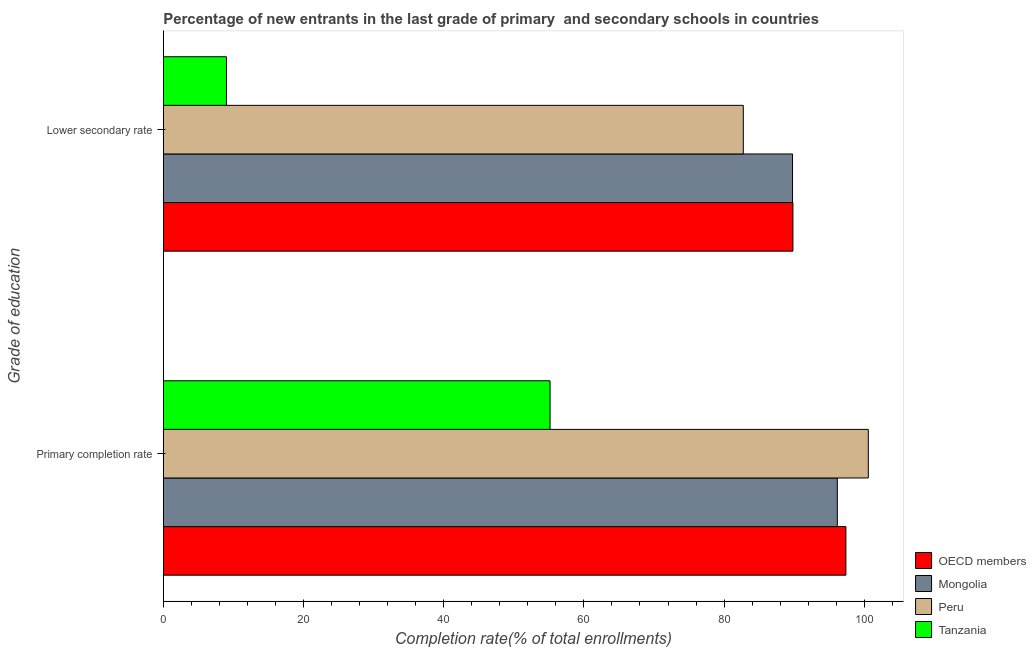How many different coloured bars are there?
Ensure brevity in your answer.  4. How many groups of bars are there?
Your answer should be compact. 2. Are the number of bars per tick equal to the number of legend labels?
Offer a very short reply. Yes. How many bars are there on the 2nd tick from the bottom?
Offer a terse response. 4. What is the label of the 2nd group of bars from the top?
Offer a terse response. Primary completion rate. What is the completion rate in primary schools in Tanzania?
Provide a succinct answer. 55.18. Across all countries, what is the maximum completion rate in primary schools?
Offer a terse response. 100.57. Across all countries, what is the minimum completion rate in secondary schools?
Provide a succinct answer. 9.02. In which country was the completion rate in primary schools maximum?
Your answer should be compact. Peru. In which country was the completion rate in primary schools minimum?
Offer a terse response. Tanzania. What is the total completion rate in primary schools in the graph?
Provide a succinct answer. 349.28. What is the difference between the completion rate in primary schools in OECD members and that in Tanzania?
Provide a short and direct response. 42.2. What is the difference between the completion rate in secondary schools in OECD members and the completion rate in primary schools in Mongolia?
Ensure brevity in your answer.  -6.33. What is the average completion rate in primary schools per country?
Keep it short and to the point. 87.32. What is the difference between the completion rate in primary schools and completion rate in secondary schools in Peru?
Provide a succinct answer. 17.83. What is the ratio of the completion rate in primary schools in Peru to that in OECD members?
Keep it short and to the point. 1.03. Is the completion rate in primary schools in Mongolia less than that in OECD members?
Provide a succinct answer. Yes. In how many countries, is the completion rate in secondary schools greater than the average completion rate in secondary schools taken over all countries?
Offer a terse response. 3. What does the 2nd bar from the top in Lower secondary rate represents?
Ensure brevity in your answer.  Peru. What does the 1st bar from the bottom in Lower secondary rate represents?
Provide a short and direct response. OECD members. How many bars are there?
Your response must be concise. 8. Are all the bars in the graph horizontal?
Offer a very short reply. Yes. What is the difference between two consecutive major ticks on the X-axis?
Make the answer very short. 20. Does the graph contain any zero values?
Your answer should be compact. No. Where does the legend appear in the graph?
Keep it short and to the point. Bottom right. How many legend labels are there?
Give a very brief answer. 4. How are the legend labels stacked?
Provide a short and direct response. Vertical. What is the title of the graph?
Ensure brevity in your answer.  Percentage of new entrants in the last grade of primary  and secondary schools in countries. Does "Poland" appear as one of the legend labels in the graph?
Ensure brevity in your answer.  No. What is the label or title of the X-axis?
Ensure brevity in your answer.  Completion rate(% of total enrollments). What is the label or title of the Y-axis?
Offer a very short reply. Grade of education. What is the Completion rate(% of total enrollments) in OECD members in Primary completion rate?
Provide a succinct answer. 97.37. What is the Completion rate(% of total enrollments) in Mongolia in Primary completion rate?
Your answer should be compact. 96.15. What is the Completion rate(% of total enrollments) in Peru in Primary completion rate?
Provide a short and direct response. 100.57. What is the Completion rate(% of total enrollments) of Tanzania in Primary completion rate?
Give a very brief answer. 55.18. What is the Completion rate(% of total enrollments) of OECD members in Lower secondary rate?
Keep it short and to the point. 89.82. What is the Completion rate(% of total enrollments) of Mongolia in Lower secondary rate?
Your answer should be compact. 89.76. What is the Completion rate(% of total enrollments) of Peru in Lower secondary rate?
Provide a short and direct response. 82.74. What is the Completion rate(% of total enrollments) in Tanzania in Lower secondary rate?
Offer a very short reply. 9.02. Across all Grade of education, what is the maximum Completion rate(% of total enrollments) of OECD members?
Make the answer very short. 97.37. Across all Grade of education, what is the maximum Completion rate(% of total enrollments) of Mongolia?
Make the answer very short. 96.15. Across all Grade of education, what is the maximum Completion rate(% of total enrollments) in Peru?
Offer a very short reply. 100.57. Across all Grade of education, what is the maximum Completion rate(% of total enrollments) of Tanzania?
Provide a short and direct response. 55.18. Across all Grade of education, what is the minimum Completion rate(% of total enrollments) of OECD members?
Provide a succinct answer. 89.82. Across all Grade of education, what is the minimum Completion rate(% of total enrollments) of Mongolia?
Make the answer very short. 89.76. Across all Grade of education, what is the minimum Completion rate(% of total enrollments) in Peru?
Provide a short and direct response. 82.74. Across all Grade of education, what is the minimum Completion rate(% of total enrollments) in Tanzania?
Provide a succinct answer. 9.02. What is the total Completion rate(% of total enrollments) in OECD members in the graph?
Your response must be concise. 187.19. What is the total Completion rate(% of total enrollments) in Mongolia in the graph?
Offer a terse response. 185.92. What is the total Completion rate(% of total enrollments) of Peru in the graph?
Your response must be concise. 183.31. What is the total Completion rate(% of total enrollments) in Tanzania in the graph?
Keep it short and to the point. 64.19. What is the difference between the Completion rate(% of total enrollments) of OECD members in Primary completion rate and that in Lower secondary rate?
Your answer should be very brief. 7.56. What is the difference between the Completion rate(% of total enrollments) of Mongolia in Primary completion rate and that in Lower secondary rate?
Your response must be concise. 6.39. What is the difference between the Completion rate(% of total enrollments) in Peru in Primary completion rate and that in Lower secondary rate?
Ensure brevity in your answer.  17.83. What is the difference between the Completion rate(% of total enrollments) in Tanzania in Primary completion rate and that in Lower secondary rate?
Provide a short and direct response. 46.16. What is the difference between the Completion rate(% of total enrollments) in OECD members in Primary completion rate and the Completion rate(% of total enrollments) in Mongolia in Lower secondary rate?
Your answer should be compact. 7.61. What is the difference between the Completion rate(% of total enrollments) in OECD members in Primary completion rate and the Completion rate(% of total enrollments) in Peru in Lower secondary rate?
Your answer should be compact. 14.63. What is the difference between the Completion rate(% of total enrollments) in OECD members in Primary completion rate and the Completion rate(% of total enrollments) in Tanzania in Lower secondary rate?
Offer a terse response. 88.36. What is the difference between the Completion rate(% of total enrollments) in Mongolia in Primary completion rate and the Completion rate(% of total enrollments) in Peru in Lower secondary rate?
Make the answer very short. 13.41. What is the difference between the Completion rate(% of total enrollments) of Mongolia in Primary completion rate and the Completion rate(% of total enrollments) of Tanzania in Lower secondary rate?
Keep it short and to the point. 87.14. What is the difference between the Completion rate(% of total enrollments) of Peru in Primary completion rate and the Completion rate(% of total enrollments) of Tanzania in Lower secondary rate?
Offer a terse response. 91.56. What is the average Completion rate(% of total enrollments) in OECD members per Grade of education?
Keep it short and to the point. 93.6. What is the average Completion rate(% of total enrollments) of Mongolia per Grade of education?
Provide a short and direct response. 92.96. What is the average Completion rate(% of total enrollments) in Peru per Grade of education?
Offer a terse response. 91.66. What is the average Completion rate(% of total enrollments) of Tanzania per Grade of education?
Offer a terse response. 32.1. What is the difference between the Completion rate(% of total enrollments) of OECD members and Completion rate(% of total enrollments) of Mongolia in Primary completion rate?
Your response must be concise. 1.22. What is the difference between the Completion rate(% of total enrollments) in OECD members and Completion rate(% of total enrollments) in Peru in Primary completion rate?
Offer a very short reply. -3.2. What is the difference between the Completion rate(% of total enrollments) in OECD members and Completion rate(% of total enrollments) in Tanzania in Primary completion rate?
Provide a succinct answer. 42.2. What is the difference between the Completion rate(% of total enrollments) of Mongolia and Completion rate(% of total enrollments) of Peru in Primary completion rate?
Provide a short and direct response. -4.42. What is the difference between the Completion rate(% of total enrollments) in Mongolia and Completion rate(% of total enrollments) in Tanzania in Primary completion rate?
Your answer should be very brief. 40.97. What is the difference between the Completion rate(% of total enrollments) of Peru and Completion rate(% of total enrollments) of Tanzania in Primary completion rate?
Provide a succinct answer. 45.39. What is the difference between the Completion rate(% of total enrollments) of OECD members and Completion rate(% of total enrollments) of Mongolia in Lower secondary rate?
Keep it short and to the point. 0.06. What is the difference between the Completion rate(% of total enrollments) of OECD members and Completion rate(% of total enrollments) of Peru in Lower secondary rate?
Offer a very short reply. 7.08. What is the difference between the Completion rate(% of total enrollments) of OECD members and Completion rate(% of total enrollments) of Tanzania in Lower secondary rate?
Your response must be concise. 80.8. What is the difference between the Completion rate(% of total enrollments) of Mongolia and Completion rate(% of total enrollments) of Peru in Lower secondary rate?
Make the answer very short. 7.02. What is the difference between the Completion rate(% of total enrollments) of Mongolia and Completion rate(% of total enrollments) of Tanzania in Lower secondary rate?
Provide a short and direct response. 80.75. What is the difference between the Completion rate(% of total enrollments) of Peru and Completion rate(% of total enrollments) of Tanzania in Lower secondary rate?
Provide a short and direct response. 73.73. What is the ratio of the Completion rate(% of total enrollments) of OECD members in Primary completion rate to that in Lower secondary rate?
Your answer should be compact. 1.08. What is the ratio of the Completion rate(% of total enrollments) in Mongolia in Primary completion rate to that in Lower secondary rate?
Provide a succinct answer. 1.07. What is the ratio of the Completion rate(% of total enrollments) in Peru in Primary completion rate to that in Lower secondary rate?
Your answer should be very brief. 1.22. What is the ratio of the Completion rate(% of total enrollments) of Tanzania in Primary completion rate to that in Lower secondary rate?
Your response must be concise. 6.12. What is the difference between the highest and the second highest Completion rate(% of total enrollments) of OECD members?
Offer a terse response. 7.56. What is the difference between the highest and the second highest Completion rate(% of total enrollments) in Mongolia?
Your answer should be very brief. 6.39. What is the difference between the highest and the second highest Completion rate(% of total enrollments) of Peru?
Give a very brief answer. 17.83. What is the difference between the highest and the second highest Completion rate(% of total enrollments) in Tanzania?
Provide a short and direct response. 46.16. What is the difference between the highest and the lowest Completion rate(% of total enrollments) in OECD members?
Provide a short and direct response. 7.56. What is the difference between the highest and the lowest Completion rate(% of total enrollments) in Mongolia?
Your response must be concise. 6.39. What is the difference between the highest and the lowest Completion rate(% of total enrollments) in Peru?
Your response must be concise. 17.83. What is the difference between the highest and the lowest Completion rate(% of total enrollments) of Tanzania?
Offer a terse response. 46.16. 